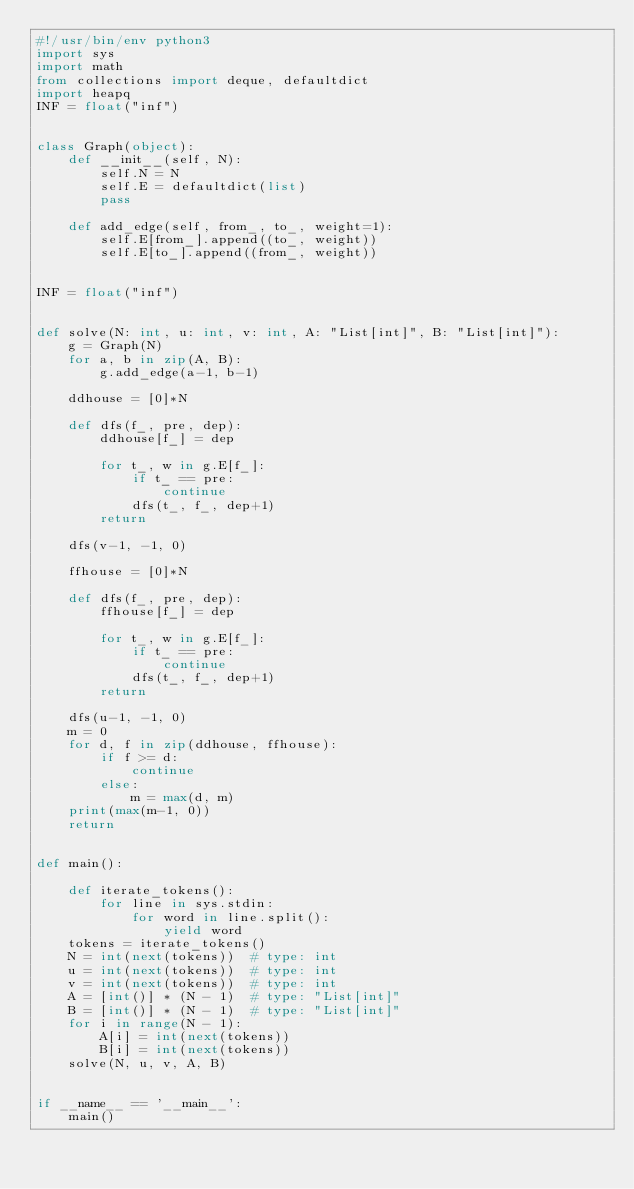<code> <loc_0><loc_0><loc_500><loc_500><_Python_>#!/usr/bin/env python3
import sys
import math
from collections import deque, defaultdict
import heapq
INF = float("inf")


class Graph(object):
    def __init__(self, N):
        self.N = N
        self.E = defaultdict(list)
        pass

    def add_edge(self, from_, to_, weight=1):
        self.E[from_].append((to_, weight))
        self.E[to_].append((from_, weight))


INF = float("inf")


def solve(N: int, u: int, v: int, A: "List[int]", B: "List[int]"):
    g = Graph(N)
    for a, b in zip(A, B):
        g.add_edge(a-1, b-1)

    ddhouse = [0]*N

    def dfs(f_, pre, dep):
        ddhouse[f_] = dep

        for t_, w in g.E[f_]:
            if t_ == pre:
                continue
            dfs(t_, f_, dep+1)
        return

    dfs(v-1, -1, 0)

    ffhouse = [0]*N

    def dfs(f_, pre, dep):
        ffhouse[f_] = dep

        for t_, w in g.E[f_]:
            if t_ == pre:
                continue
            dfs(t_, f_, dep+1)
        return

    dfs(u-1, -1, 0)
    m = 0
    for d, f in zip(ddhouse, ffhouse):
        if f >= d:
            continue
        else:
            m = max(d, m)
    print(max(m-1, 0))
    return


def main():

    def iterate_tokens():
        for line in sys.stdin:
            for word in line.split():
                yield word
    tokens = iterate_tokens()
    N = int(next(tokens))  # type: int
    u = int(next(tokens))  # type: int
    v = int(next(tokens))  # type: int
    A = [int()] * (N - 1)  # type: "List[int]"
    B = [int()] * (N - 1)  # type: "List[int]"
    for i in range(N - 1):
        A[i] = int(next(tokens))
        B[i] = int(next(tokens))
    solve(N, u, v, A, B)


if __name__ == '__main__':
    main()
</code> 